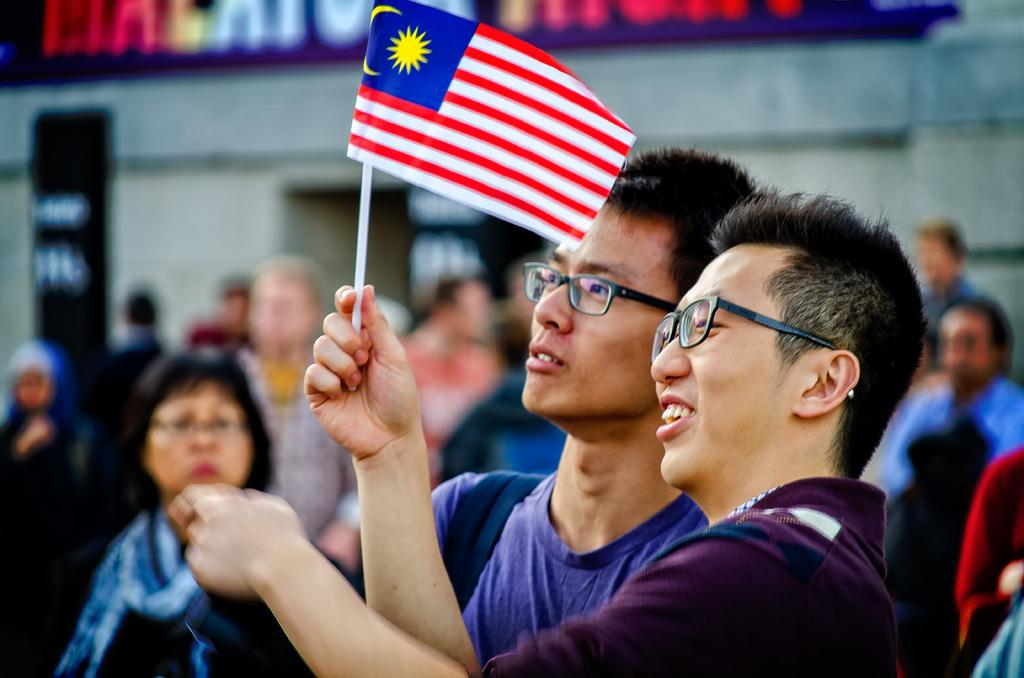Who or what can be seen in the image? There are people in the image. What is visible in the background of the image? There is a wall with text in the background of the image. What are two people doing in the foreground of the image? Two people are holding a red and white flag in the foreground of the image. What type of damage can be seen from the earthquake in the image? There is no earthquake or any damage visible in the image. How tall are the giants in the image? There are no giants present in the image. 